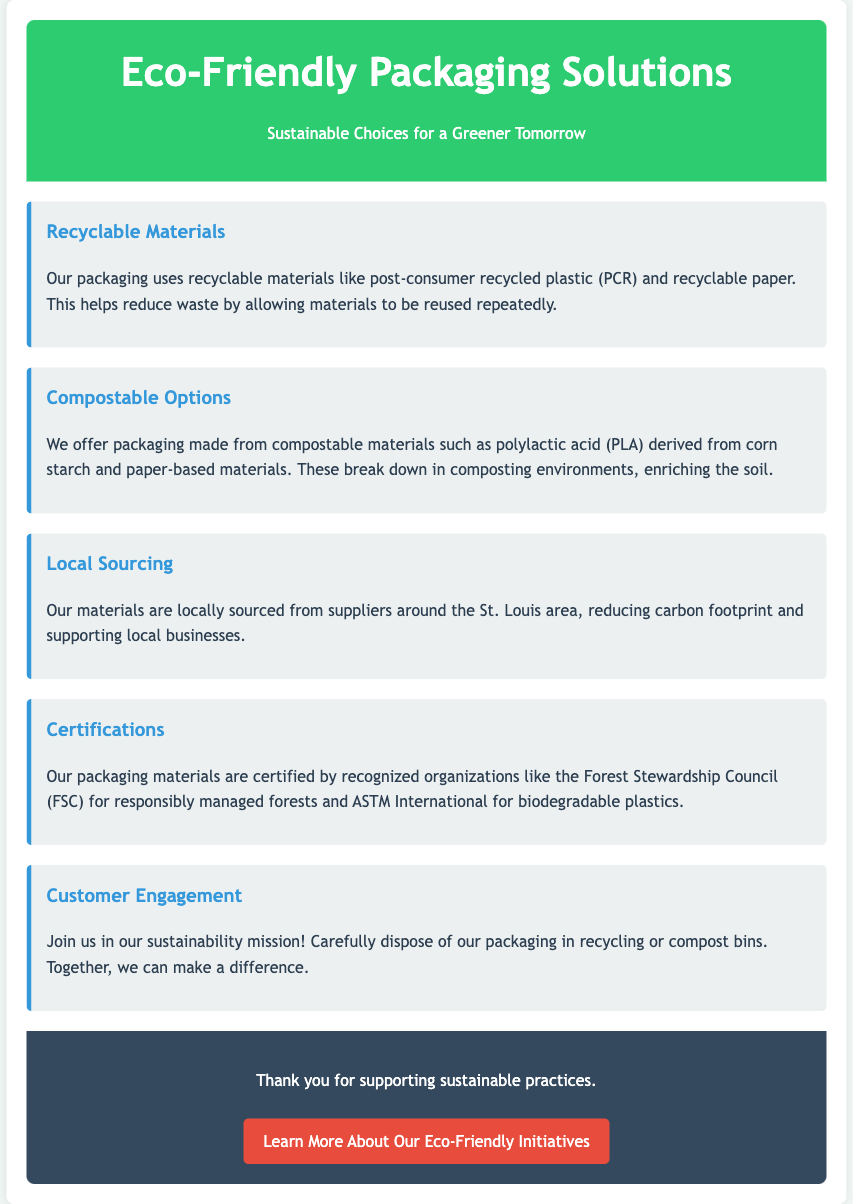What materials are used for recyclable packaging? The recyclable packaging uses post-consumer recycled plastic (PCR) and recyclable paper.
Answer: PCR and recyclable paper What is the source of the compostable materials? The compostable materials are derived from corn starch and paper-based materials.
Answer: Corn starch and paper-based materials Where are the materials for packaging sourced from? The materials are locally sourced from suppliers around the St. Louis area.
Answer: St. Louis area What are the certifications mentioned for packaging materials? The packaging materials are certified by the Forest Stewardship Council (FSC) and ASTM International.
Answer: FSC and ASTM International What does the document encourage customers to do with packaging? The document encourages customers to carefully dispose of packaging in recycling or compost bins.
Answer: Dispose in recycling or compost bins Why is local sourcing emphasized in the document? Local sourcing is emphasized to reduce carbon footprint and support local businesses.
Answer: Reduce carbon footprint and support local businesses What type of packaging material is derived from corn starch? The packaging material derived from corn starch is polylactic acid (PLA).
Answer: Polylactic acid (PLA) Which color is used for the header background? The header background is colored green.
Answer: Green 